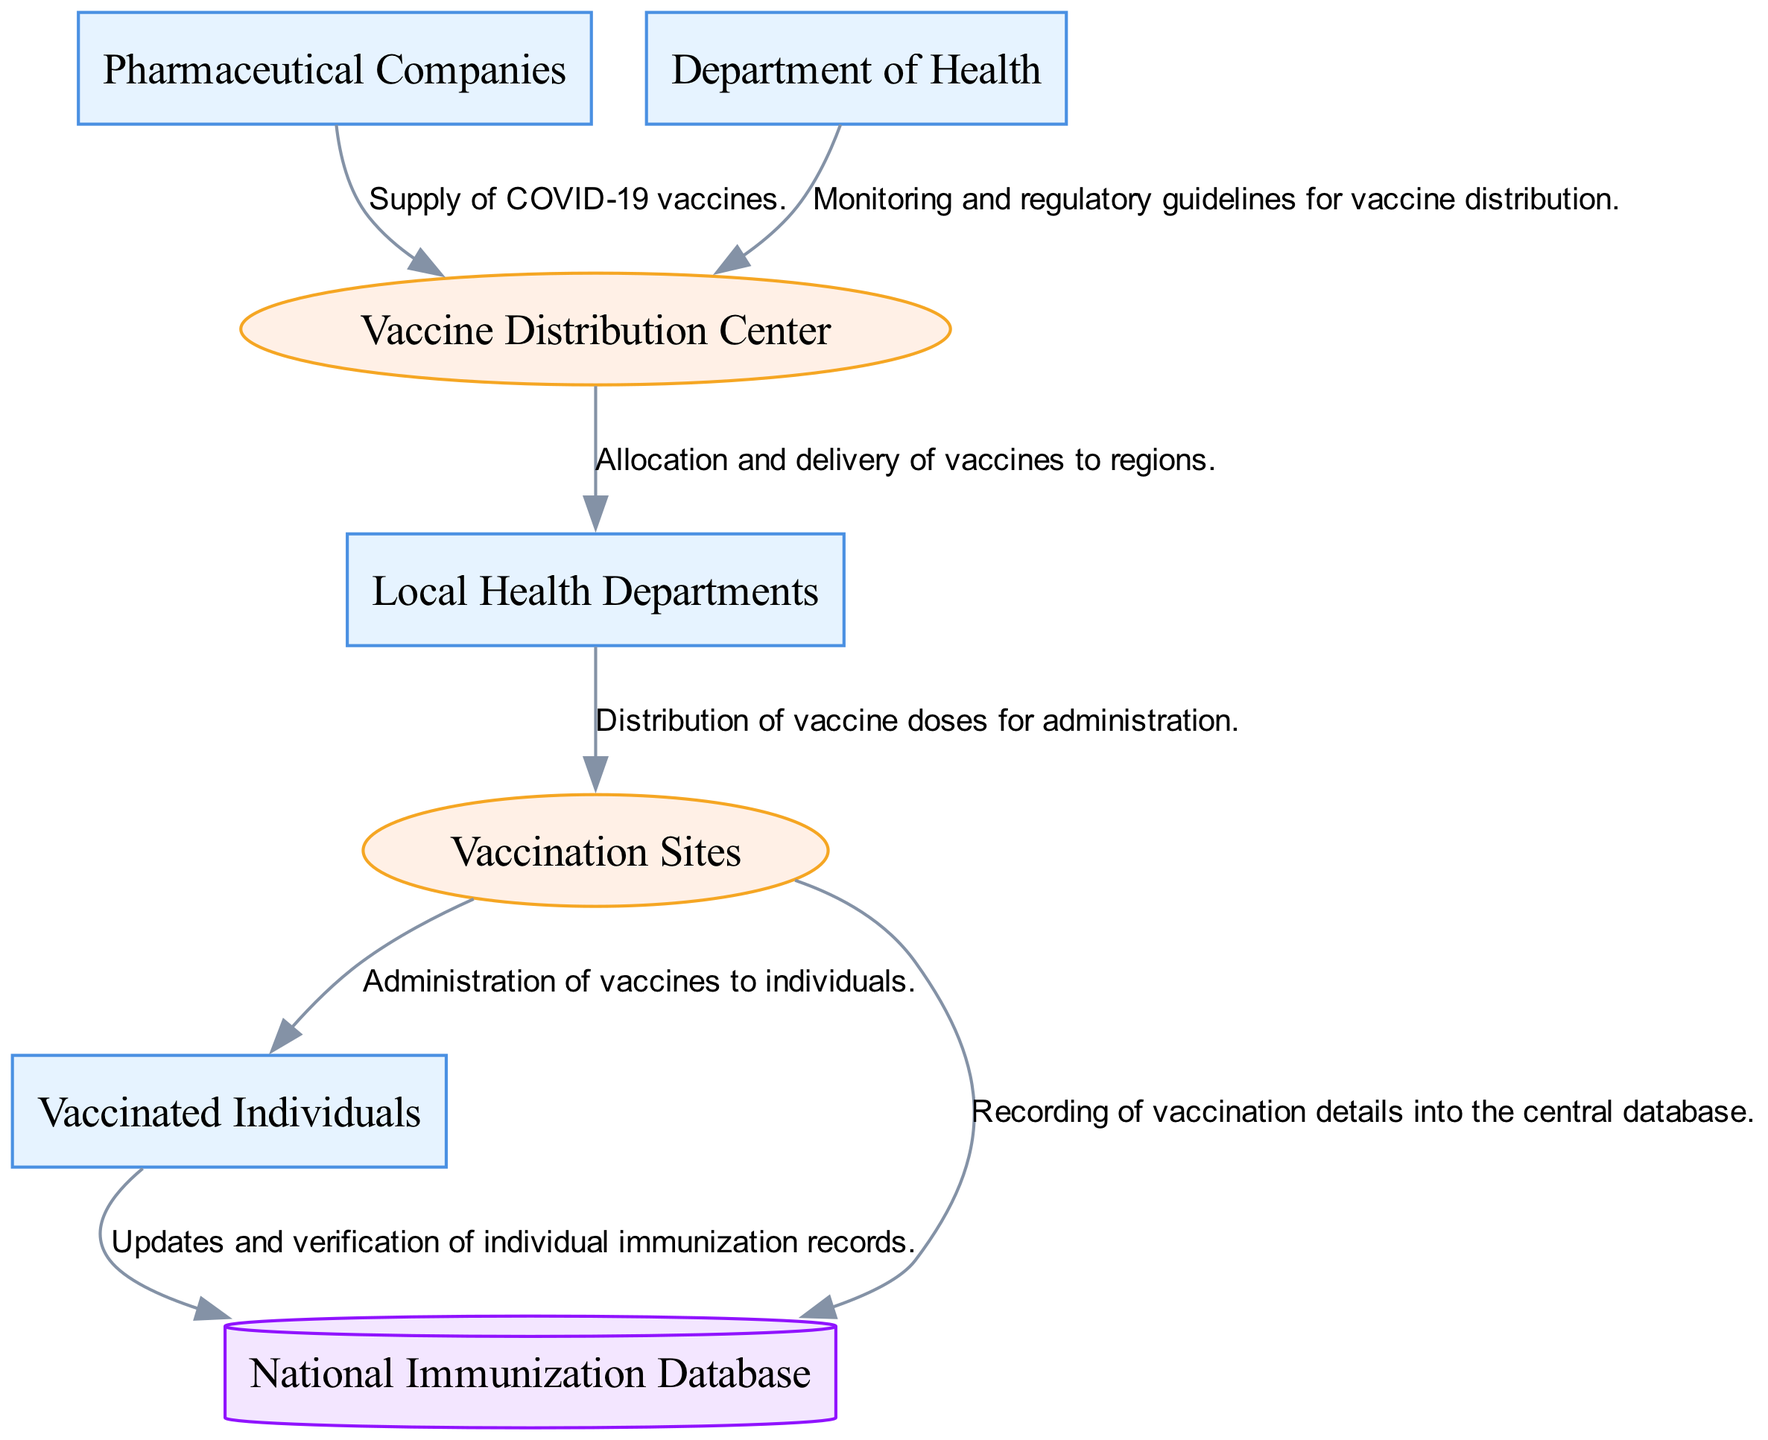What are the external entities involved in the diagram? The diagram lists three external entities: Pharmaceutical Companies, Department of Health, and Local Health Departments.
Answer: Pharmaceutical Companies, Department of Health, Local Health Departments How many processes are represented in the diagram? The diagram depicts two processes: Vaccine Distribution Center and Vaccination Sites.
Answer: Two What type of data store is included in this diagram? The diagram includes one data store, which is the National Immunization Database.
Answer: National Immunization Database What is the relationship between Local Health Departments and Vaccination Sites? Local Health Departments distribute vaccine doses for administration to Vaccination Sites. This flow specifies a direct allocation role from Local Health Departments to Vaccination Sites.
Answer: Distribution of vaccine doses What entity supplies vaccines to the Vaccine Distribution Center? The source of vaccine supply to the Vaccine Distribution Center is the Pharmaceutical Companies.
Answer: Pharmaceutical Companies What is the process that records vaccination details into the central database? The process is executed at the Vaccination Sites, where vaccination details are recorded into the National Immunization Database.
Answer: Vaccination Sites How do vaccinated individuals update their records? Vaccinated Individuals send updates and verify their immunization records in the National Immunization Database. This indicates a two-way interaction between vaccinated individuals and the data store.
Answer: Updates and verification Which entity provides regulatory guidelines for vaccine distribution? The Department of Health is responsible for monitoring and providing regulatory guidelines for the Vaccine Distribution Center.
Answer: Department of Health What type of diagram is this? This is a Data Flow Diagram, which illustrates the flow of data within a system, showing how different entities interact and process information.
Answer: Data Flow Diagram 